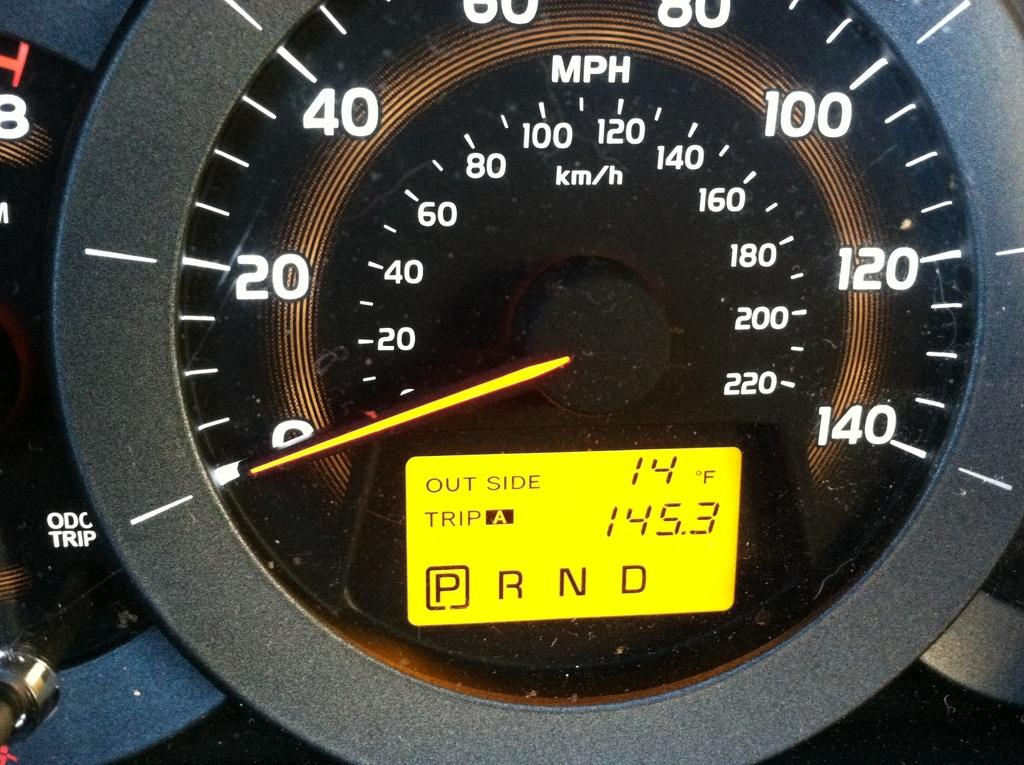What is the main object in the foreground of the image? There is a speed meter in the foreground of the image. What feature of the speed meter is mentioned in the facts? The speed meter has a needle. What information does the speed meter display? The speed meter displays readings and units. What color is the ink on the toes of the person in the image? There is no person or toes visible in the image; it only features a speed meter. Can you tell me how many links are in the chain attached to the speed meter? There is no chain attached to the speed meter in the image. 